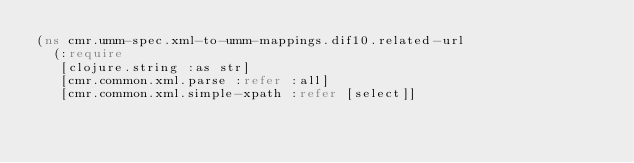Convert code to text. <code><loc_0><loc_0><loc_500><loc_500><_Clojure_>(ns cmr.umm-spec.xml-to-umm-mappings.dif10.related-url
  (:require
   [clojure.string :as str]
   [cmr.common.xml.parse :refer :all]
   [cmr.common.xml.simple-xpath :refer [select]]</code> 